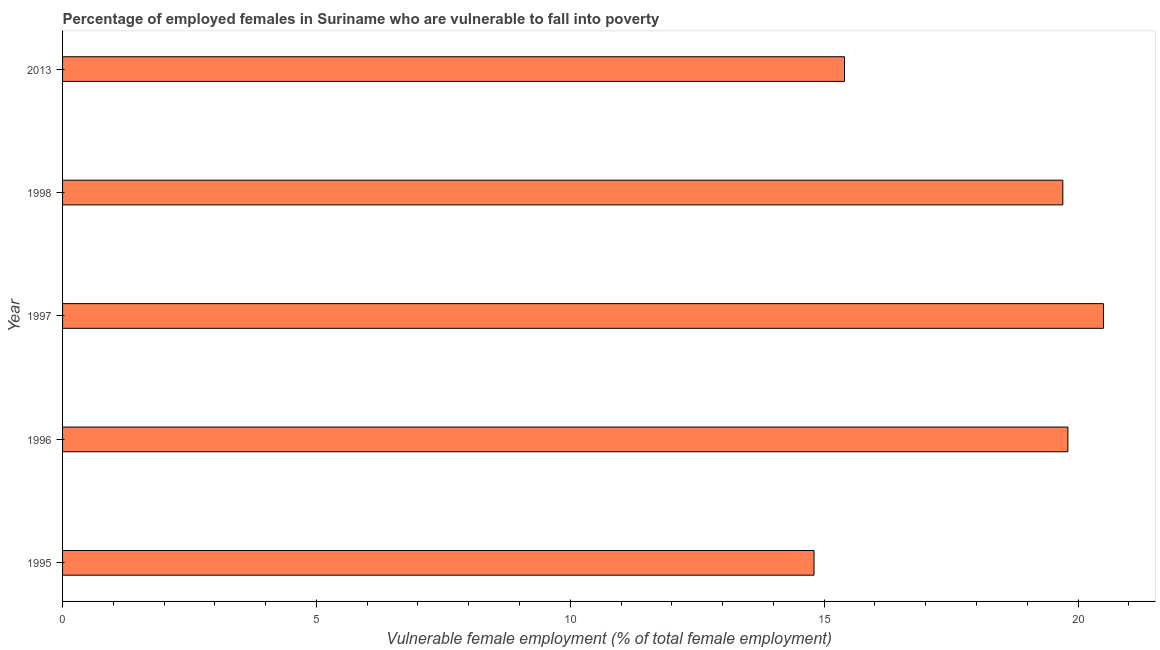What is the title of the graph?
Your answer should be very brief. Percentage of employed females in Suriname who are vulnerable to fall into poverty. What is the label or title of the X-axis?
Offer a very short reply. Vulnerable female employment (% of total female employment). What is the label or title of the Y-axis?
Ensure brevity in your answer.  Year. What is the percentage of employed females who are vulnerable to fall into poverty in 1995?
Your answer should be compact. 14.8. Across all years, what is the maximum percentage of employed females who are vulnerable to fall into poverty?
Your answer should be compact. 20.5. Across all years, what is the minimum percentage of employed females who are vulnerable to fall into poverty?
Offer a very short reply. 14.8. In which year was the percentage of employed females who are vulnerable to fall into poverty maximum?
Your response must be concise. 1997. What is the sum of the percentage of employed females who are vulnerable to fall into poverty?
Provide a succinct answer. 90.2. What is the difference between the percentage of employed females who are vulnerable to fall into poverty in 1997 and 2013?
Your response must be concise. 5.1. What is the average percentage of employed females who are vulnerable to fall into poverty per year?
Offer a very short reply. 18.04. What is the median percentage of employed females who are vulnerable to fall into poverty?
Keep it short and to the point. 19.7. Do a majority of the years between 1998 and 2013 (inclusive) have percentage of employed females who are vulnerable to fall into poverty greater than 11 %?
Offer a very short reply. Yes. What is the ratio of the percentage of employed females who are vulnerable to fall into poverty in 1996 to that in 1997?
Give a very brief answer. 0.97. Is the difference between the percentage of employed females who are vulnerable to fall into poverty in 1995 and 2013 greater than the difference between any two years?
Make the answer very short. No. What is the difference between the highest and the second highest percentage of employed females who are vulnerable to fall into poverty?
Your answer should be very brief. 0.7. Is the sum of the percentage of employed females who are vulnerable to fall into poverty in 1997 and 1998 greater than the maximum percentage of employed females who are vulnerable to fall into poverty across all years?
Your answer should be compact. Yes. What is the difference between the highest and the lowest percentage of employed females who are vulnerable to fall into poverty?
Ensure brevity in your answer.  5.7. In how many years, is the percentage of employed females who are vulnerable to fall into poverty greater than the average percentage of employed females who are vulnerable to fall into poverty taken over all years?
Make the answer very short. 3. How many bars are there?
Keep it short and to the point. 5. Are the values on the major ticks of X-axis written in scientific E-notation?
Offer a very short reply. No. What is the Vulnerable female employment (% of total female employment) in 1995?
Your answer should be compact. 14.8. What is the Vulnerable female employment (% of total female employment) in 1996?
Provide a short and direct response. 19.8. What is the Vulnerable female employment (% of total female employment) of 1997?
Give a very brief answer. 20.5. What is the Vulnerable female employment (% of total female employment) in 1998?
Ensure brevity in your answer.  19.7. What is the Vulnerable female employment (% of total female employment) of 2013?
Your answer should be very brief. 15.4. What is the difference between the Vulnerable female employment (% of total female employment) in 1995 and 1998?
Provide a short and direct response. -4.9. What is the difference between the Vulnerable female employment (% of total female employment) in 1996 and 1998?
Provide a short and direct response. 0.1. What is the difference between the Vulnerable female employment (% of total female employment) in 1996 and 2013?
Provide a succinct answer. 4.4. What is the difference between the Vulnerable female employment (% of total female employment) in 1997 and 1998?
Make the answer very short. 0.8. What is the ratio of the Vulnerable female employment (% of total female employment) in 1995 to that in 1996?
Ensure brevity in your answer.  0.75. What is the ratio of the Vulnerable female employment (% of total female employment) in 1995 to that in 1997?
Offer a terse response. 0.72. What is the ratio of the Vulnerable female employment (% of total female employment) in 1995 to that in 1998?
Keep it short and to the point. 0.75. What is the ratio of the Vulnerable female employment (% of total female employment) in 1995 to that in 2013?
Your response must be concise. 0.96. What is the ratio of the Vulnerable female employment (% of total female employment) in 1996 to that in 1997?
Provide a succinct answer. 0.97. What is the ratio of the Vulnerable female employment (% of total female employment) in 1996 to that in 1998?
Your response must be concise. 1. What is the ratio of the Vulnerable female employment (% of total female employment) in 1996 to that in 2013?
Provide a succinct answer. 1.29. What is the ratio of the Vulnerable female employment (% of total female employment) in 1997 to that in 1998?
Ensure brevity in your answer.  1.04. What is the ratio of the Vulnerable female employment (% of total female employment) in 1997 to that in 2013?
Your answer should be compact. 1.33. What is the ratio of the Vulnerable female employment (% of total female employment) in 1998 to that in 2013?
Provide a succinct answer. 1.28. 